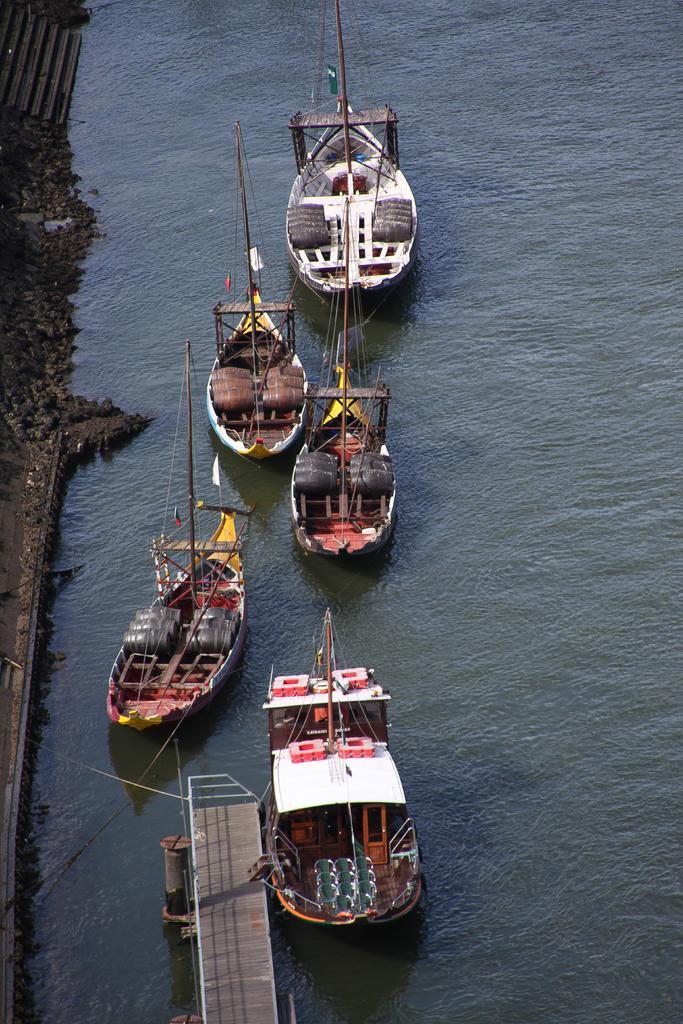In one or two sentences, can you explain what this image depicts? In this picture I can see many boats on the water. At the bottom there is a bridge and fencing. On the left I can see the stones and railing. In the top left I can see the stairs. 